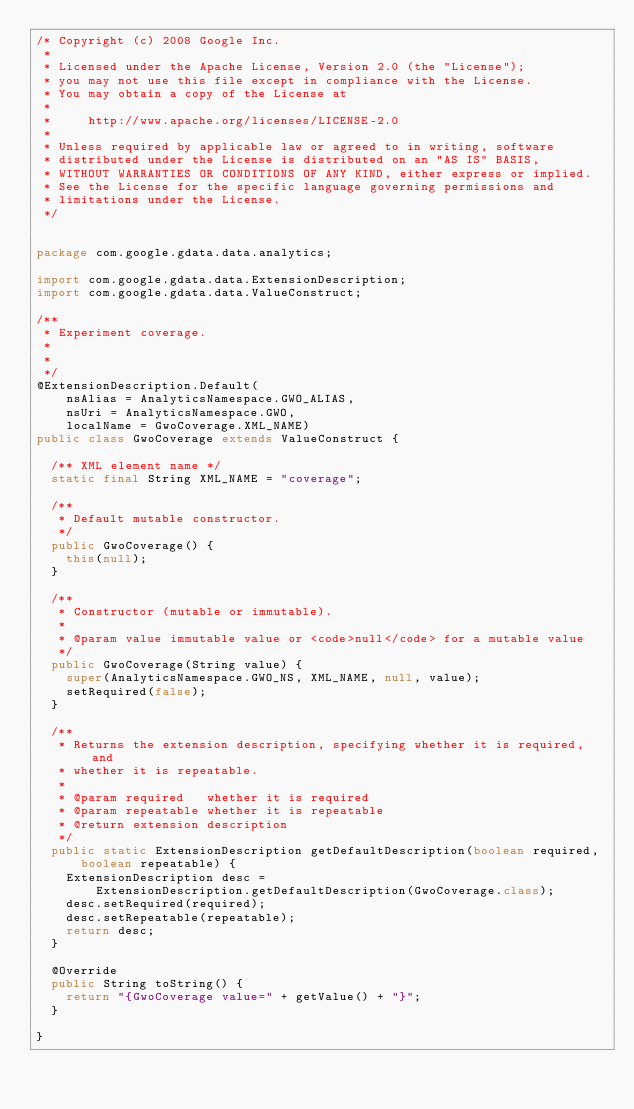Convert code to text. <code><loc_0><loc_0><loc_500><loc_500><_Java_>/* Copyright (c) 2008 Google Inc.
 *
 * Licensed under the Apache License, Version 2.0 (the "License");
 * you may not use this file except in compliance with the License.
 * You may obtain a copy of the License at
 *
 *     http://www.apache.org/licenses/LICENSE-2.0
 *
 * Unless required by applicable law or agreed to in writing, software
 * distributed under the License is distributed on an "AS IS" BASIS,
 * WITHOUT WARRANTIES OR CONDITIONS OF ANY KIND, either express or implied.
 * See the License for the specific language governing permissions and
 * limitations under the License.
 */


package com.google.gdata.data.analytics;

import com.google.gdata.data.ExtensionDescription;
import com.google.gdata.data.ValueConstruct;

/**
 * Experiment coverage.
 *
 * 
 */
@ExtensionDescription.Default(
    nsAlias = AnalyticsNamespace.GWO_ALIAS,
    nsUri = AnalyticsNamespace.GWO,
    localName = GwoCoverage.XML_NAME)
public class GwoCoverage extends ValueConstruct {

  /** XML element name */
  static final String XML_NAME = "coverage";

  /**
   * Default mutable constructor.
   */
  public GwoCoverage() {
    this(null);
  }

  /**
   * Constructor (mutable or immutable).
   *
   * @param value immutable value or <code>null</code> for a mutable value
   */
  public GwoCoverage(String value) {
    super(AnalyticsNamespace.GWO_NS, XML_NAME, null, value);
    setRequired(false);
  }

  /**
   * Returns the extension description, specifying whether it is required, and
   * whether it is repeatable.
   *
   * @param required   whether it is required
   * @param repeatable whether it is repeatable
   * @return extension description
   */
  public static ExtensionDescription getDefaultDescription(boolean required,
      boolean repeatable) {
    ExtensionDescription desc =
        ExtensionDescription.getDefaultDescription(GwoCoverage.class);
    desc.setRequired(required);
    desc.setRepeatable(repeatable);
    return desc;
  }

  @Override
  public String toString() {
    return "{GwoCoverage value=" + getValue() + "}";
  }

}

</code> 